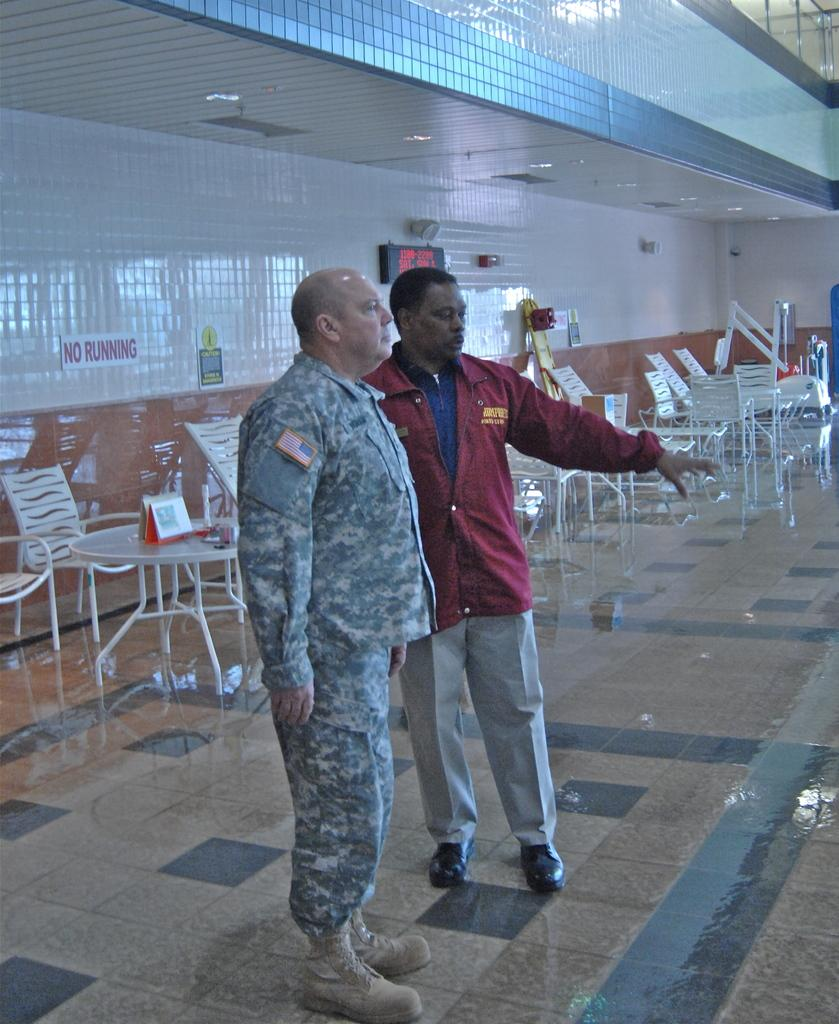How many people are in the image? There are two men in the image. What are the men doing in the image? The men are standing. Can you describe the clothing of one of the men? One of the men is wearing a uniform. What type of furniture can be seen in the background of the image? There are chairs and tables in the background of the image. What type of bone can be seen on the table in the image? There is no bone present on the table in the image. What type of poison is being used by one of the men in the image? There is no indication of poison or any dangerous substance in the image; the men are simply standing. 